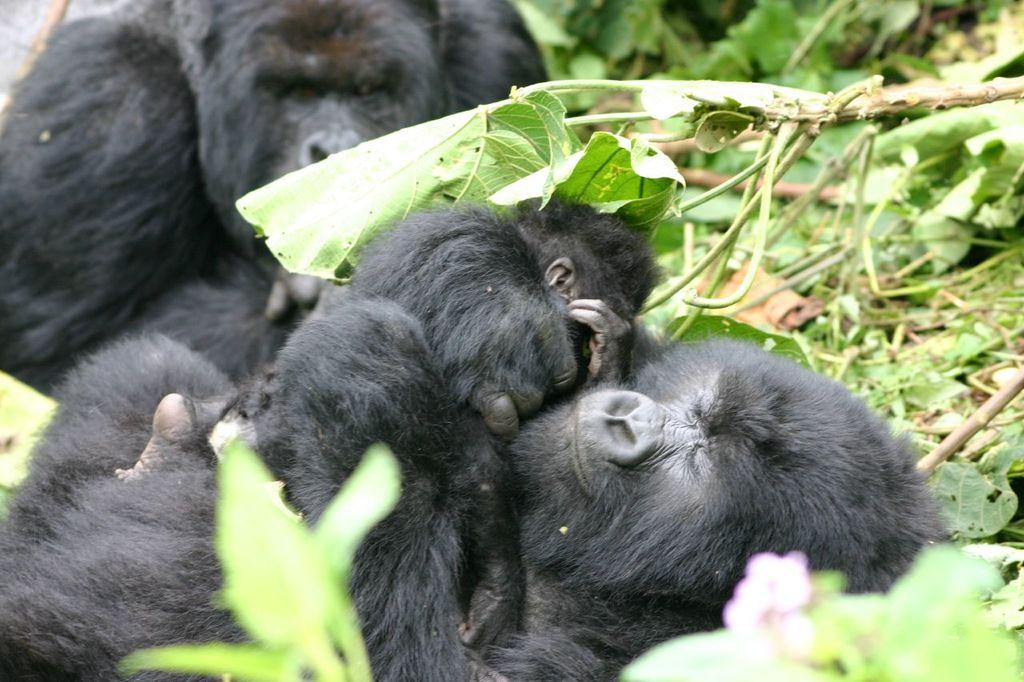What type of animals are in the image? There are chimpanzees in the image. What can be seen in the background of the image? There are trees in the background of the image. What type of slave is depicted in the image? There is no slave depicted in the image; it features chimpanzees and trees. What type of underwear can be seen on the chimpanzees in the image? There is no underwear present in the image; the chimpanzees are not wearing any clothing. 